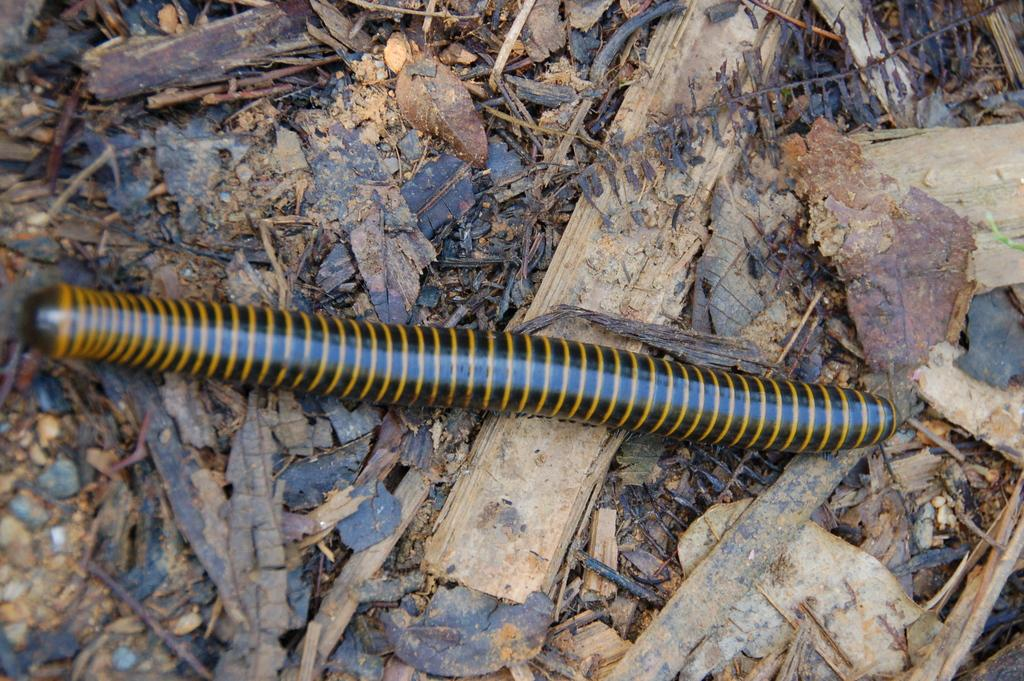What is present in the picture? There is an insect in the picture. What is the insect doing in the picture? The insect is crawling on dry leaves. Can you describe the appearance of the insect? The insect has a yellow and black color. What type of transport can be seen in the image? There is no transport present in the image; it features an insect crawling on dry leaves. What kind of engine is visible in the image? There is no engine present in the image. 